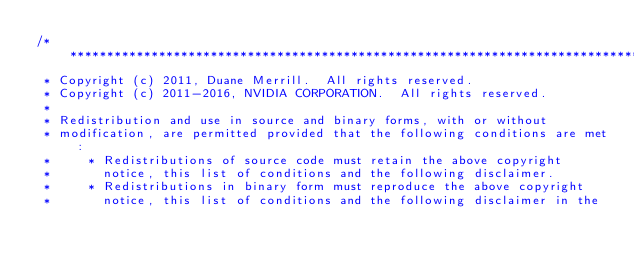<code> <loc_0><loc_0><loc_500><loc_500><_Cuda_>/******************************************************************************
 * Copyright (c) 2011, Duane Merrill.  All rights reserved.
 * Copyright (c) 2011-2016, NVIDIA CORPORATION.  All rights reserved.
 *
 * Redistribution and use in source and binary forms, with or without
 * modification, are permitted provided that the following conditions are met:
 *     * Redistributions of source code must retain the above copyright
 *       notice, this list of conditions and the following disclaimer.
 *     * Redistributions in binary form must reproduce the above copyright
 *       notice, this list of conditions and the following disclaimer in the</code> 